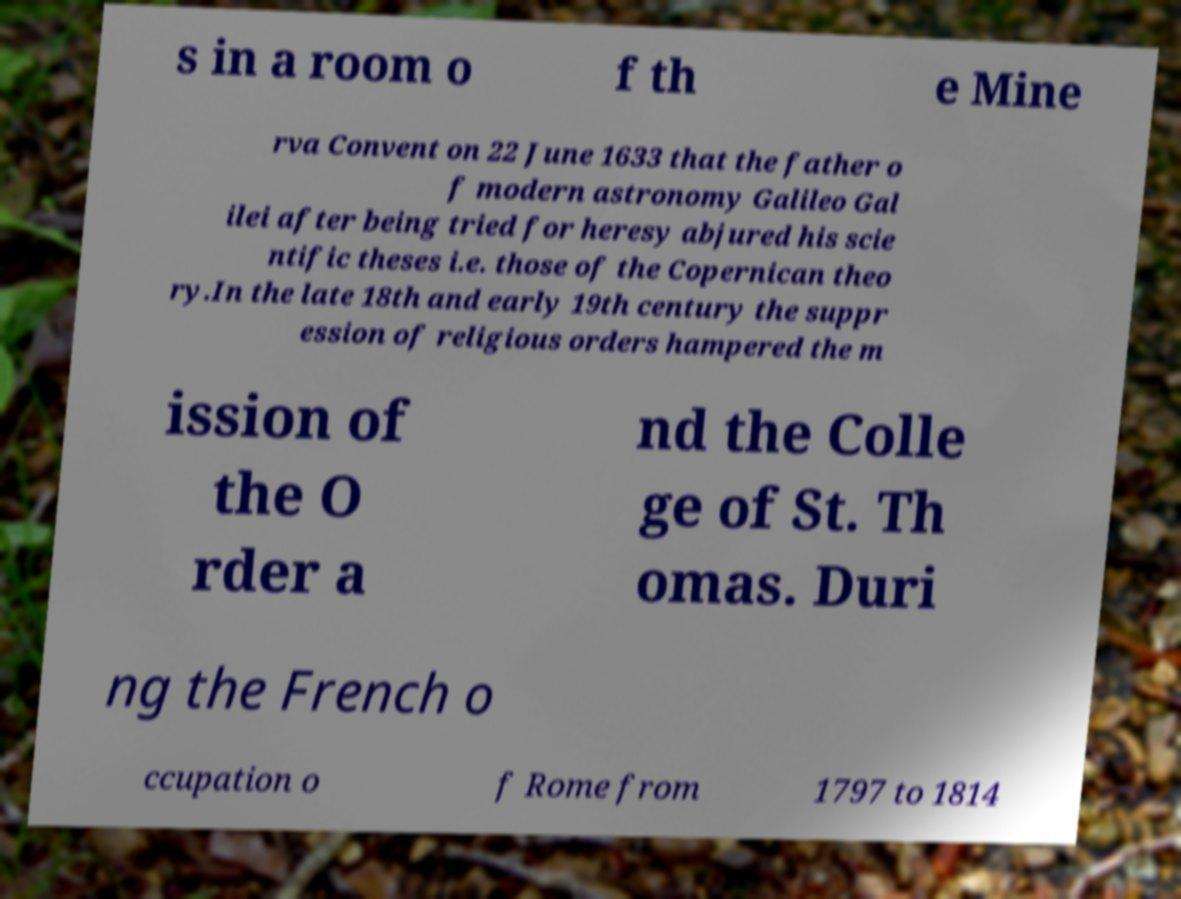Can you read and provide the text displayed in the image?This photo seems to have some interesting text. Can you extract and type it out for me? s in a room o f th e Mine rva Convent on 22 June 1633 that the father o f modern astronomy Galileo Gal ilei after being tried for heresy abjured his scie ntific theses i.e. those of the Copernican theo ry.In the late 18th and early 19th century the suppr ession of religious orders hampered the m ission of the O rder a nd the Colle ge of St. Th omas. Duri ng the French o ccupation o f Rome from 1797 to 1814 